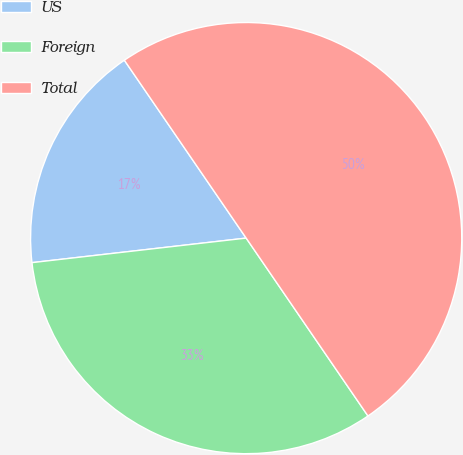Convert chart. <chart><loc_0><loc_0><loc_500><loc_500><pie_chart><fcel>US<fcel>Foreign<fcel>Total<nl><fcel>17.26%<fcel>32.74%<fcel>50.0%<nl></chart> 